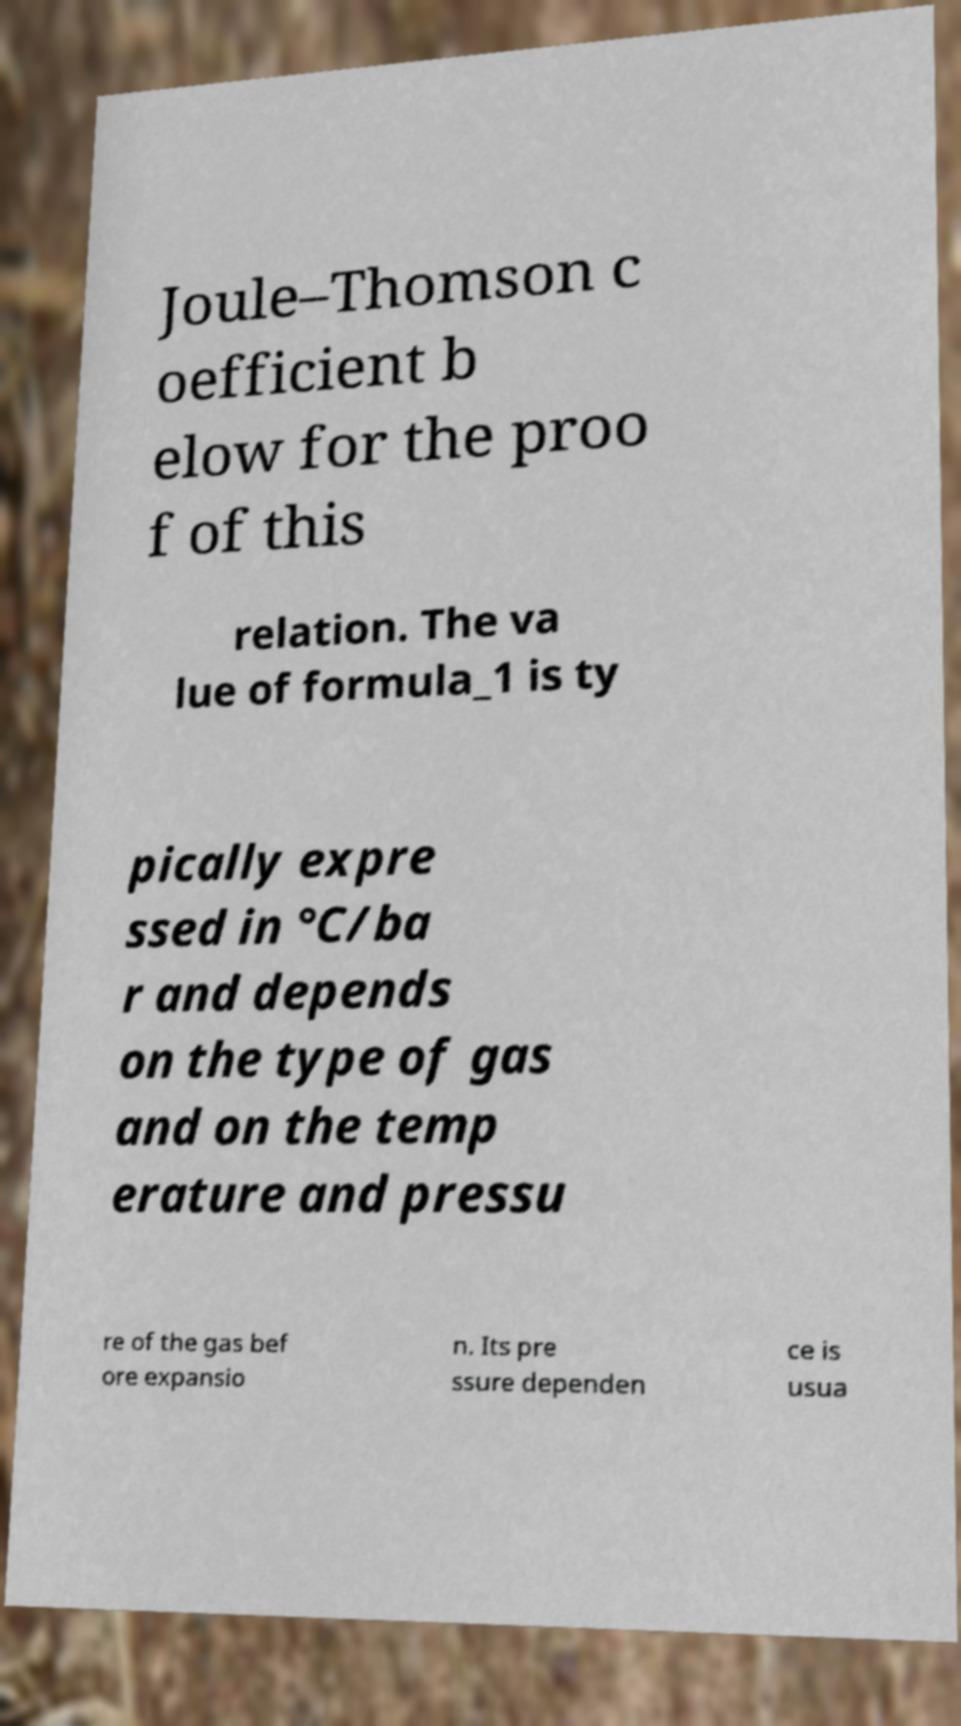What messages or text are displayed in this image? I need them in a readable, typed format. Joule–Thomson c oefficient b elow for the proo f of this relation. The va lue of formula_1 is ty pically expre ssed in °C/ba r and depends on the type of gas and on the temp erature and pressu re of the gas bef ore expansio n. Its pre ssure dependen ce is usua 